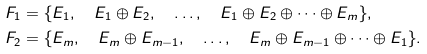Convert formula to latex. <formula><loc_0><loc_0><loc_500><loc_500>& F _ { 1 } = \{ E _ { 1 } , \quad E _ { 1 } \oplus E _ { 2 } , \quad \dots , \quad E _ { 1 } \oplus E _ { 2 } \oplus \dots \oplus E _ { m } \} , \\ & F _ { 2 } = \{ E _ { m } , \quad E _ { m } \oplus E _ { m - 1 } , \quad \dots , \quad E _ { m } \oplus E _ { m - 1 } \oplus \dots \oplus E _ { 1 } \} . \\</formula> 